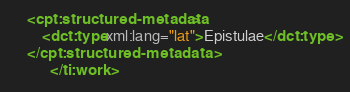<code> <loc_0><loc_0><loc_500><loc_500><_XML_>    <cpt:structured-metadata>
        <dct:type xml:lang="lat">Epistulae</dct:type>
    </cpt:structured-metadata>
          </ti:work>
</code> 